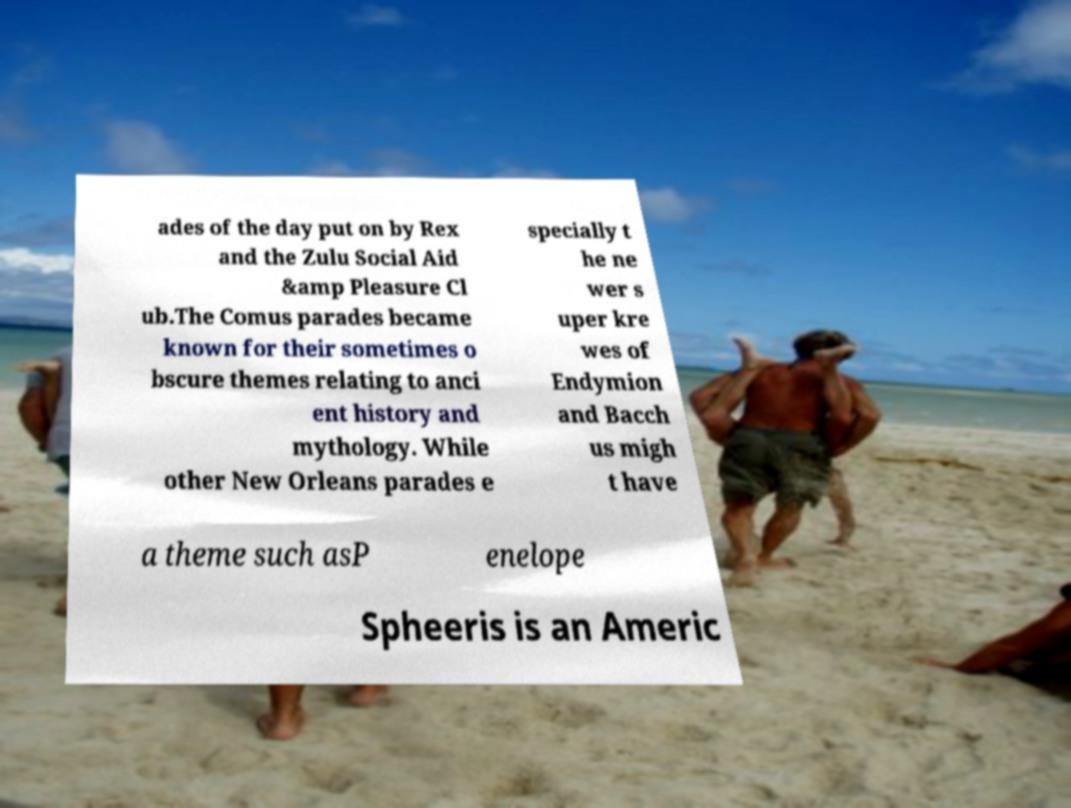There's text embedded in this image that I need extracted. Can you transcribe it verbatim? ades of the day put on by Rex and the Zulu Social Aid &amp Pleasure Cl ub.The Comus parades became known for their sometimes o bscure themes relating to anci ent history and mythology. While other New Orleans parades e specially t he ne wer s uper kre wes of Endymion and Bacch us migh t have a theme such asP enelope Spheeris is an Americ 